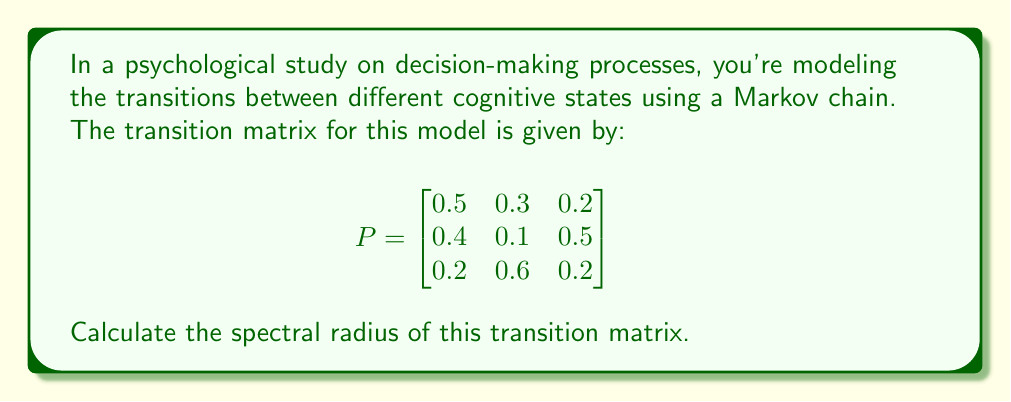Solve this math problem. To calculate the spectral radius of the transition matrix, we need to follow these steps:

1) The spectral radius is defined as the largest absolute value of the eigenvalues of the matrix.

2) To find the eigenvalues, we need to solve the characteristic equation:

   $\det(P - \lambda I) = 0$

   where $I$ is the 3x3 identity matrix and $\lambda$ represents the eigenvalues.

3) Expanding the determinant:

   $$\begin{vmatrix}
   0.5-\lambda & 0.3 & 0.2 \\
   0.4 & 0.1-\lambda & 0.5 \\
   0.2 & 0.6 & 0.2-\lambda
   \end{vmatrix} = 0$$

4) This gives us the characteristic polynomial:

   $-\lambda^3 + 0.8\lambda^2 + 0.07\lambda + 0.13 = 0$

5) Solving this cubic equation (you can use the cubic formula or numerical methods), we get the eigenvalues:

   $\lambda_1 \approx 1$
   $\lambda_2 \approx -0.1$
   $\lambda_3 \approx -0.1$

6) The spectral radius is the largest absolute value among these eigenvalues:

   $\rho(P) = \max(|1|, |-0.1|, |-0.1|) = 1$

Note: The largest eigenvalue of a stochastic matrix (like this transition matrix) is always 1.
Answer: $1$ 